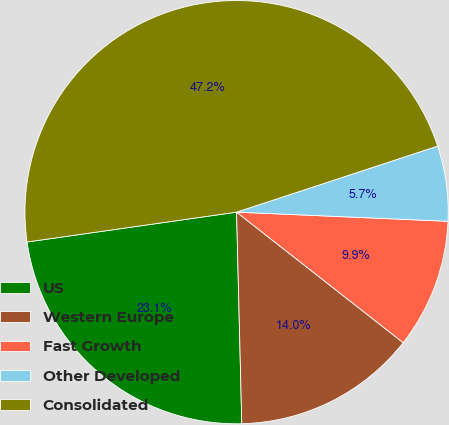Convert chart to OTSL. <chart><loc_0><loc_0><loc_500><loc_500><pie_chart><fcel>US<fcel>Western Europe<fcel>Fast Growth<fcel>Other Developed<fcel>Consolidated<nl><fcel>23.14%<fcel>14.03%<fcel>9.89%<fcel>5.74%<fcel>47.2%<nl></chart> 